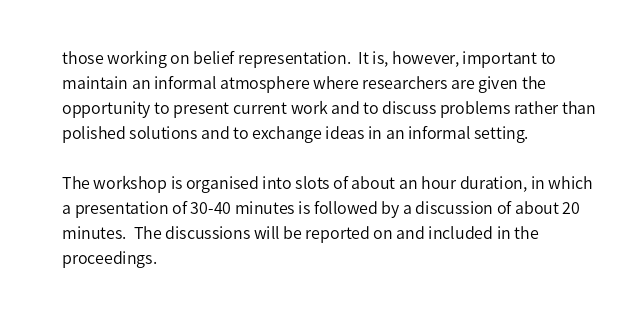Convert code to text. <code><loc_0><loc_0><loc_500><loc_500><_HTML_>those working on belief representation.  It is, however, important to
maintain an informal atmosphere where researchers are given the
opportunity to present current work and to discuss problems rather than
polished solutions and to exchange ideas in an informal setting.

The workshop is organised into slots of about an hour duration, in which
a presentation of 30-40 minutes is followed by a discussion of about 20
minutes.  The discussions will be reported on and included in the
proceedings.
</code> 